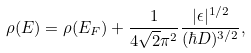Convert formula to latex. <formula><loc_0><loc_0><loc_500><loc_500>\rho ( E ) = \rho ( E _ { F } ) + \frac { 1 } { 4 \sqrt { 2 } \pi ^ { 2 } } \frac { | \epsilon | ^ { 1 / 2 } } { ( \hbar { D } ) ^ { 3 / 2 } } ,</formula> 